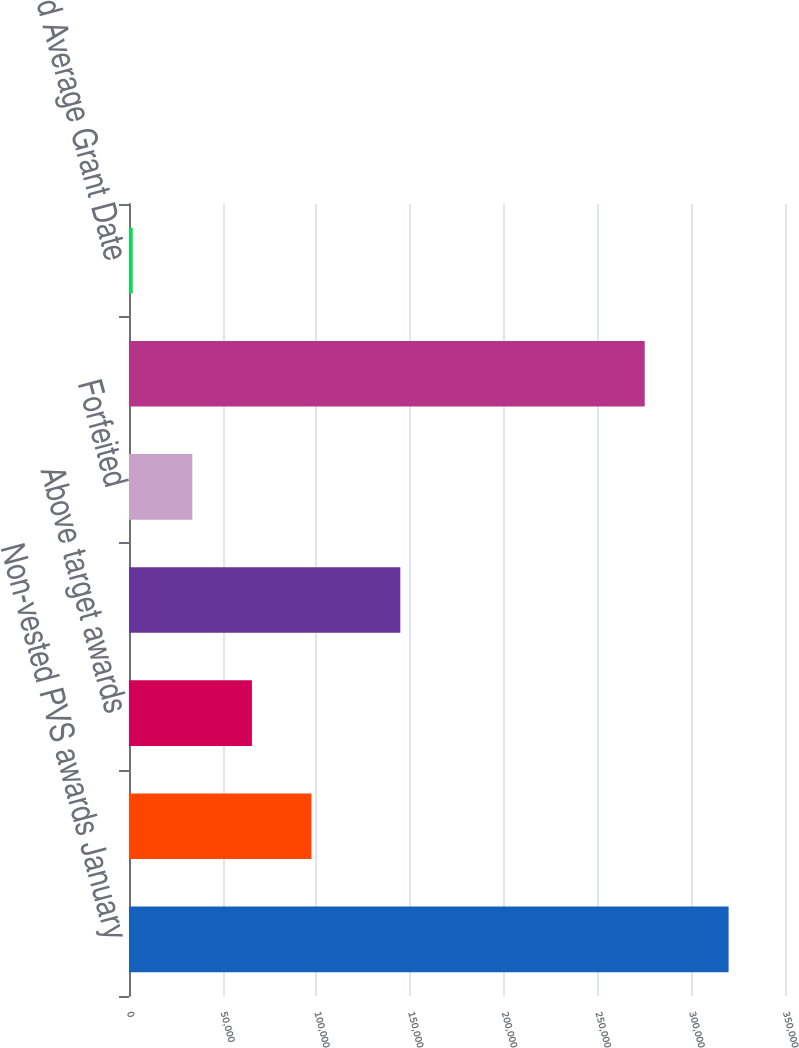Convert chart. <chart><loc_0><loc_0><loc_500><loc_500><bar_chart><fcel>Non-vested PVS awards January<fcel>Granted at target level<fcel>Above target awards<fcel>Vested and converted<fcel>Forfeited<fcel>Non-vested PVS awards December<fcel>Weighted Average Grant Date<nl><fcel>319899<fcel>97373.9<fcel>65584.6<fcel>144750<fcel>33795.3<fcel>275145<fcel>2006<nl></chart> 